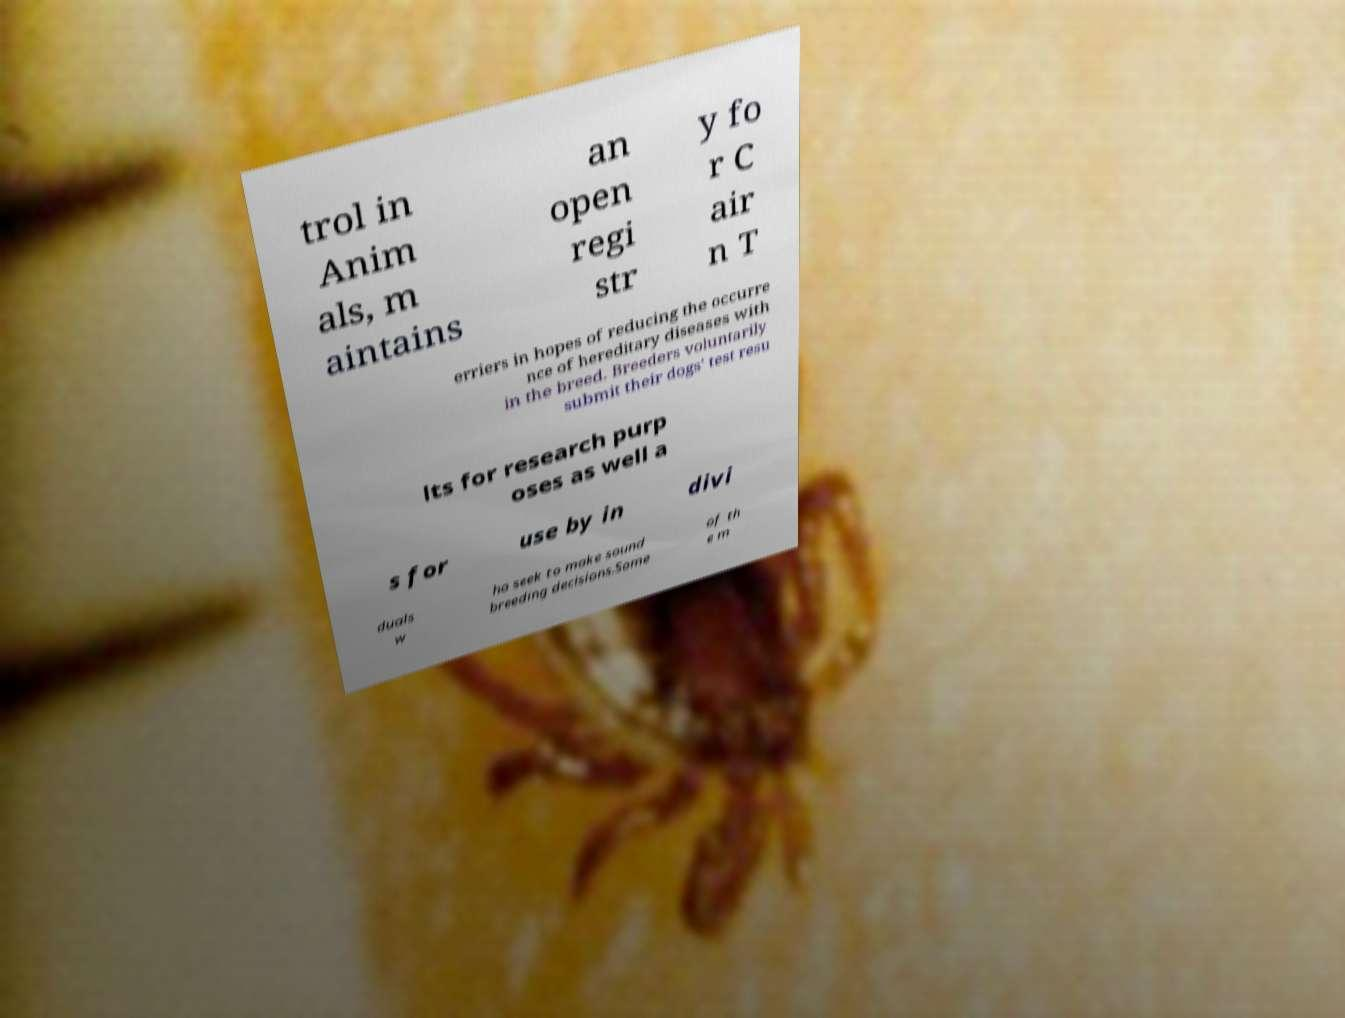I need the written content from this picture converted into text. Can you do that? trol in Anim als, m aintains an open regi str y fo r C air n T erriers in hopes of reducing the occurre nce of hereditary diseases with in the breed. Breeders voluntarily submit their dogs' test resu lts for research purp oses as well a s for use by in divi duals w ho seek to make sound breeding decisions.Some of th e m 